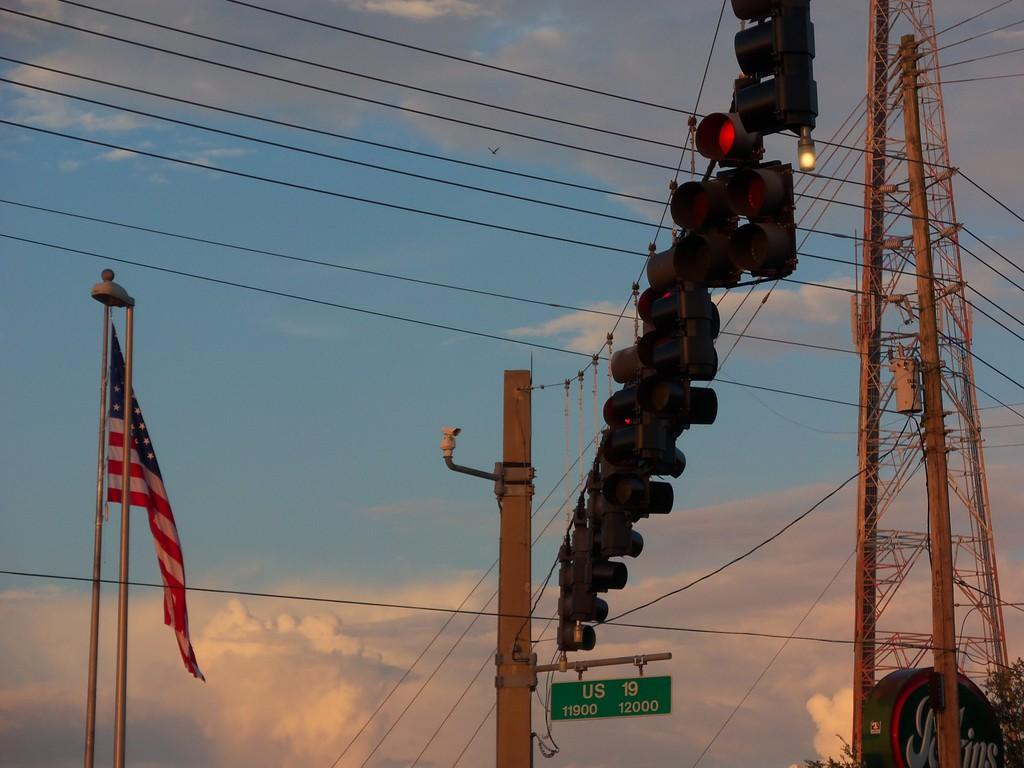<image>
Describe the image concisely. An American flag flies next to a bank of stop lights over a street sign that says, "US 19 11900 12000". 